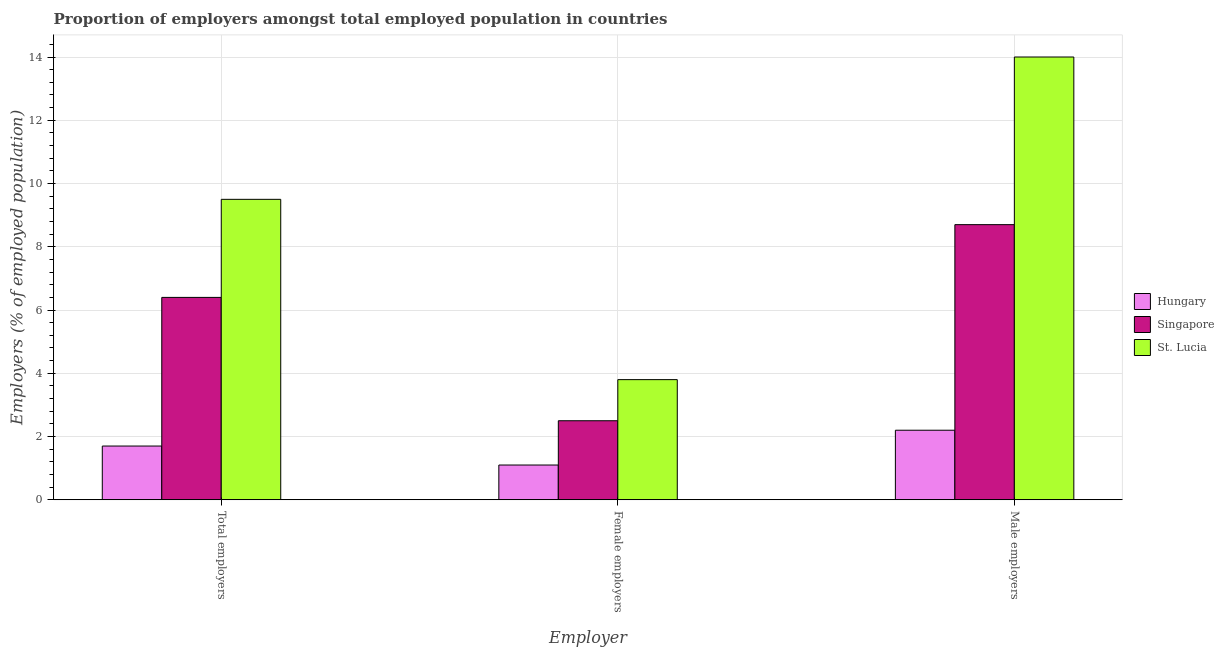Are the number of bars per tick equal to the number of legend labels?
Offer a terse response. Yes. How many bars are there on the 1st tick from the left?
Your answer should be compact. 3. What is the label of the 2nd group of bars from the left?
Provide a short and direct response. Female employers. What is the percentage of total employers in Singapore?
Your answer should be compact. 6.4. Across all countries, what is the minimum percentage of female employers?
Offer a very short reply. 1.1. In which country was the percentage of female employers maximum?
Ensure brevity in your answer.  St. Lucia. In which country was the percentage of female employers minimum?
Your answer should be compact. Hungary. What is the total percentage of total employers in the graph?
Keep it short and to the point. 17.6. What is the difference between the percentage of male employers in Singapore and that in Hungary?
Offer a terse response. 6.5. What is the average percentage of male employers per country?
Provide a succinct answer. 8.3. What is the difference between the percentage of female employers and percentage of total employers in Hungary?
Offer a very short reply. -0.6. In how many countries, is the percentage of male employers greater than 12 %?
Your response must be concise. 1. What is the ratio of the percentage of male employers in Singapore to that in St. Lucia?
Ensure brevity in your answer.  0.62. Is the percentage of total employers in St. Lucia less than that in Singapore?
Your answer should be very brief. No. Is the difference between the percentage of total employers in Hungary and Singapore greater than the difference between the percentage of female employers in Hungary and Singapore?
Ensure brevity in your answer.  No. What is the difference between the highest and the second highest percentage of female employers?
Keep it short and to the point. 1.3. What is the difference between the highest and the lowest percentage of female employers?
Make the answer very short. 2.7. In how many countries, is the percentage of total employers greater than the average percentage of total employers taken over all countries?
Make the answer very short. 2. Is the sum of the percentage of male employers in St. Lucia and Singapore greater than the maximum percentage of total employers across all countries?
Offer a very short reply. Yes. What does the 3rd bar from the left in Female employers represents?
Offer a terse response. St. Lucia. What does the 3rd bar from the right in Total employers represents?
Give a very brief answer. Hungary. Is it the case that in every country, the sum of the percentage of total employers and percentage of female employers is greater than the percentage of male employers?
Your response must be concise. No. How many countries are there in the graph?
Keep it short and to the point. 3. Are the values on the major ticks of Y-axis written in scientific E-notation?
Provide a succinct answer. No. Does the graph contain any zero values?
Keep it short and to the point. No. Does the graph contain grids?
Ensure brevity in your answer.  Yes. Where does the legend appear in the graph?
Offer a very short reply. Center right. What is the title of the graph?
Your answer should be compact. Proportion of employers amongst total employed population in countries. Does "Other small states" appear as one of the legend labels in the graph?
Your answer should be compact. No. What is the label or title of the X-axis?
Your response must be concise. Employer. What is the label or title of the Y-axis?
Give a very brief answer. Employers (% of employed population). What is the Employers (% of employed population) in Hungary in Total employers?
Give a very brief answer. 1.7. What is the Employers (% of employed population) of Singapore in Total employers?
Ensure brevity in your answer.  6.4. What is the Employers (% of employed population) in St. Lucia in Total employers?
Provide a short and direct response. 9.5. What is the Employers (% of employed population) in Hungary in Female employers?
Keep it short and to the point. 1.1. What is the Employers (% of employed population) of Singapore in Female employers?
Give a very brief answer. 2.5. What is the Employers (% of employed population) in St. Lucia in Female employers?
Your answer should be very brief. 3.8. What is the Employers (% of employed population) in Hungary in Male employers?
Your answer should be compact. 2.2. What is the Employers (% of employed population) in Singapore in Male employers?
Provide a short and direct response. 8.7. Across all Employer, what is the maximum Employers (% of employed population) of Hungary?
Give a very brief answer. 2.2. Across all Employer, what is the maximum Employers (% of employed population) of Singapore?
Your answer should be very brief. 8.7. Across all Employer, what is the minimum Employers (% of employed population) in Hungary?
Offer a terse response. 1.1. Across all Employer, what is the minimum Employers (% of employed population) of Singapore?
Offer a very short reply. 2.5. Across all Employer, what is the minimum Employers (% of employed population) in St. Lucia?
Make the answer very short. 3.8. What is the total Employers (% of employed population) of Singapore in the graph?
Offer a very short reply. 17.6. What is the total Employers (% of employed population) of St. Lucia in the graph?
Make the answer very short. 27.3. What is the difference between the Employers (% of employed population) of Singapore in Total employers and that in Female employers?
Ensure brevity in your answer.  3.9. What is the difference between the Employers (% of employed population) in St. Lucia in Total employers and that in Female employers?
Offer a terse response. 5.7. What is the difference between the Employers (% of employed population) of Singapore in Total employers and that in Male employers?
Your response must be concise. -2.3. What is the difference between the Employers (% of employed population) of St. Lucia in Total employers and that in Male employers?
Provide a short and direct response. -4.5. What is the difference between the Employers (% of employed population) of Hungary in Female employers and that in Male employers?
Your answer should be very brief. -1.1. What is the difference between the Employers (% of employed population) of Hungary in Total employers and the Employers (% of employed population) of Singapore in Male employers?
Give a very brief answer. -7. What is the difference between the Employers (% of employed population) in Singapore in Female employers and the Employers (% of employed population) in St. Lucia in Male employers?
Provide a short and direct response. -11.5. What is the average Employers (% of employed population) of Hungary per Employer?
Your response must be concise. 1.67. What is the average Employers (% of employed population) of Singapore per Employer?
Give a very brief answer. 5.87. What is the difference between the Employers (% of employed population) of Hungary and Employers (% of employed population) of Singapore in Total employers?
Your answer should be very brief. -4.7. What is the difference between the Employers (% of employed population) of Singapore and Employers (% of employed population) of St. Lucia in Female employers?
Offer a terse response. -1.3. What is the ratio of the Employers (% of employed population) of Hungary in Total employers to that in Female employers?
Your response must be concise. 1.55. What is the ratio of the Employers (% of employed population) of Singapore in Total employers to that in Female employers?
Offer a terse response. 2.56. What is the ratio of the Employers (% of employed population) in Hungary in Total employers to that in Male employers?
Your answer should be compact. 0.77. What is the ratio of the Employers (% of employed population) in Singapore in Total employers to that in Male employers?
Your response must be concise. 0.74. What is the ratio of the Employers (% of employed population) in St. Lucia in Total employers to that in Male employers?
Your answer should be very brief. 0.68. What is the ratio of the Employers (% of employed population) of Hungary in Female employers to that in Male employers?
Your answer should be compact. 0.5. What is the ratio of the Employers (% of employed population) of Singapore in Female employers to that in Male employers?
Provide a succinct answer. 0.29. What is the ratio of the Employers (% of employed population) in St. Lucia in Female employers to that in Male employers?
Offer a terse response. 0.27. What is the difference between the highest and the second highest Employers (% of employed population) in Hungary?
Provide a succinct answer. 0.5. What is the difference between the highest and the second highest Employers (% of employed population) of St. Lucia?
Your response must be concise. 4.5. What is the difference between the highest and the lowest Employers (% of employed population) of Hungary?
Offer a very short reply. 1.1. What is the difference between the highest and the lowest Employers (% of employed population) of Singapore?
Offer a terse response. 6.2. What is the difference between the highest and the lowest Employers (% of employed population) of St. Lucia?
Give a very brief answer. 10.2. 